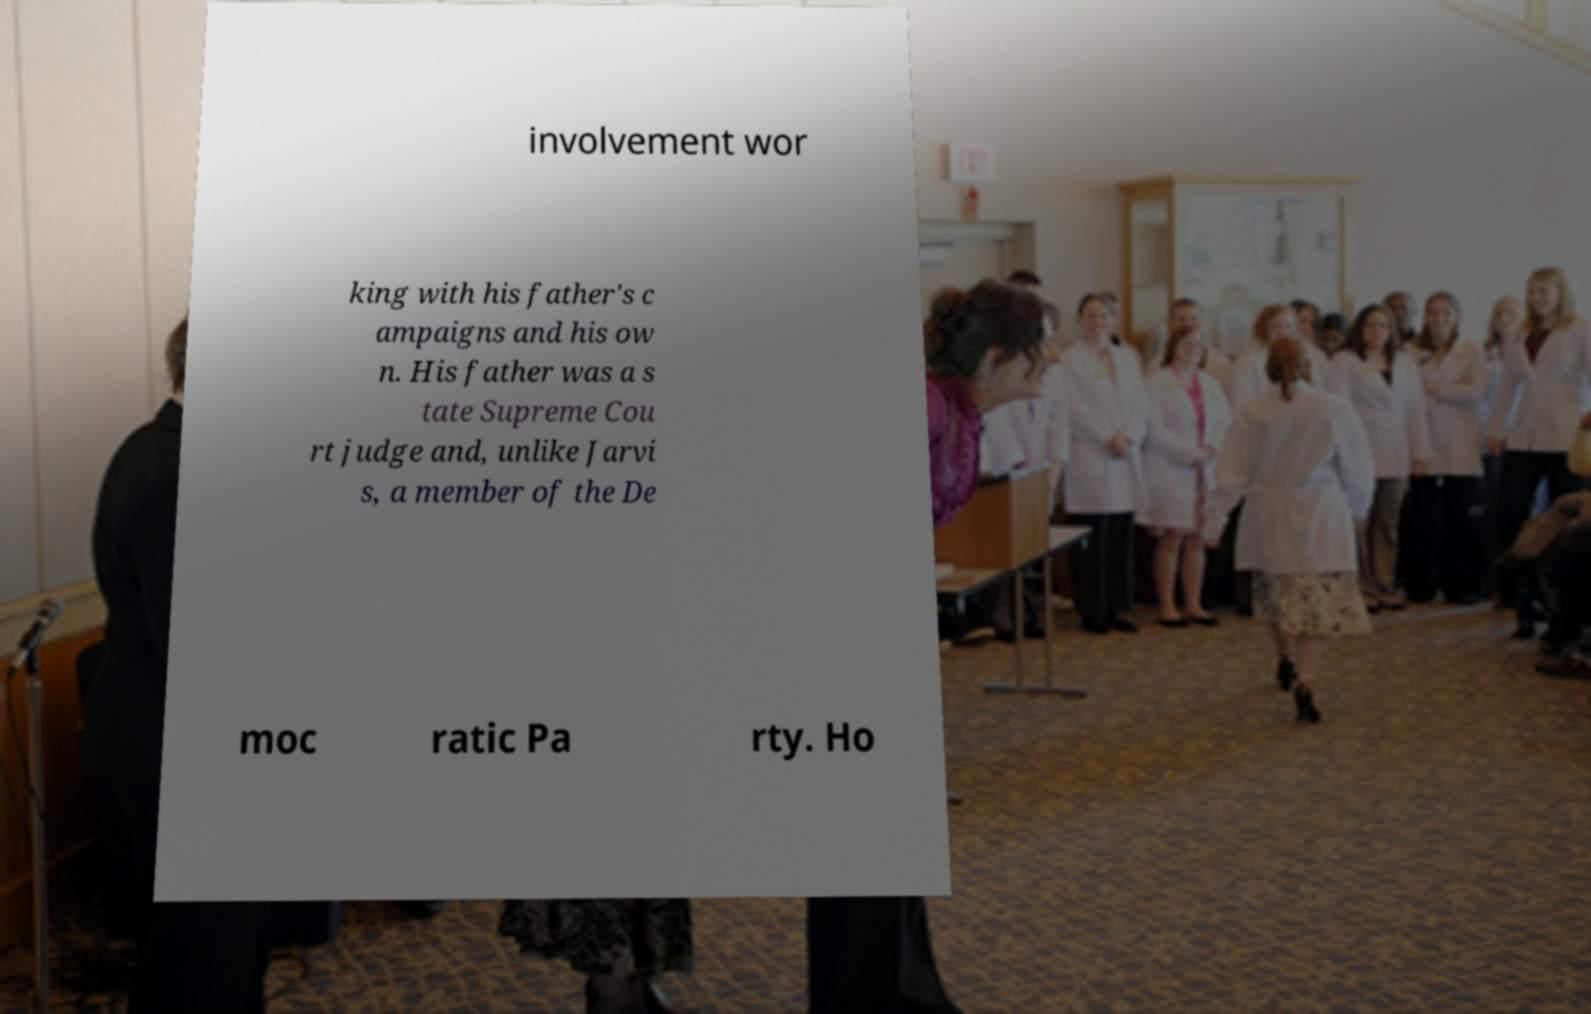Can you read and provide the text displayed in the image?This photo seems to have some interesting text. Can you extract and type it out for me? involvement wor king with his father's c ampaigns and his ow n. His father was a s tate Supreme Cou rt judge and, unlike Jarvi s, a member of the De moc ratic Pa rty. Ho 